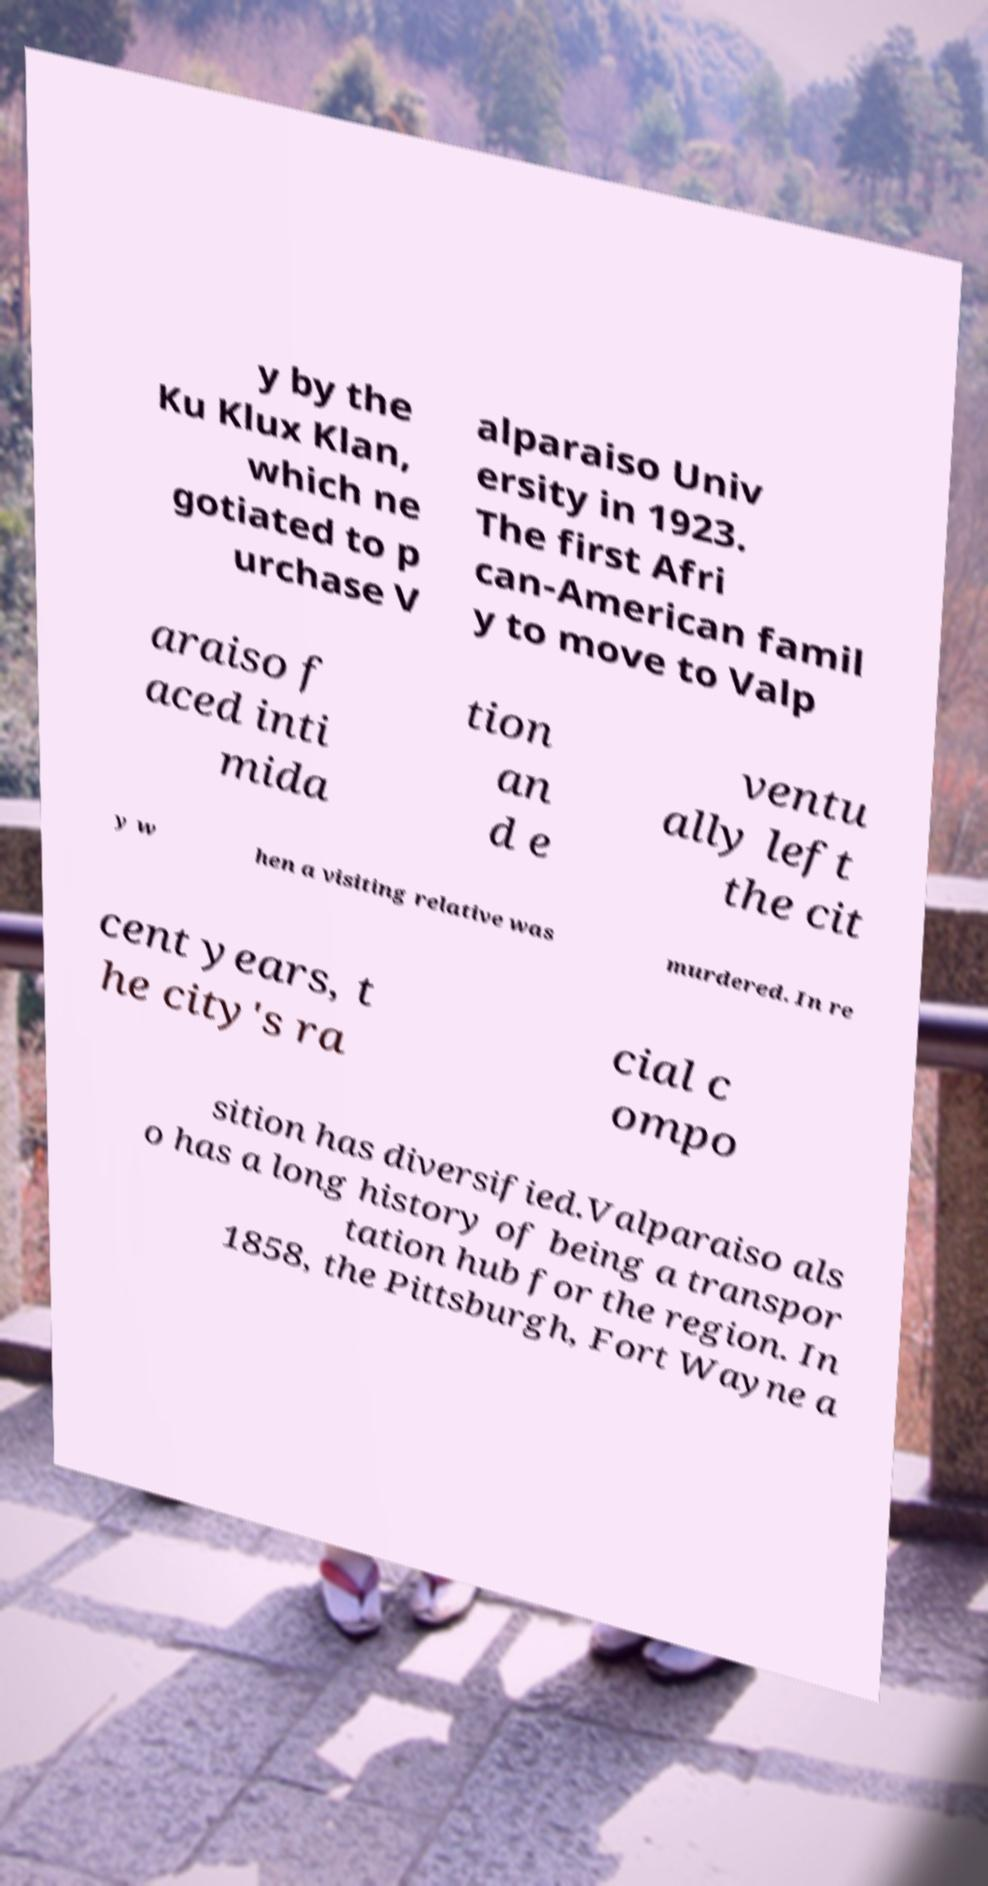For documentation purposes, I need the text within this image transcribed. Could you provide that? y by the Ku Klux Klan, which ne gotiated to p urchase V alparaiso Univ ersity in 1923. The first Afri can-American famil y to move to Valp araiso f aced inti mida tion an d e ventu ally left the cit y w hen a visiting relative was murdered. In re cent years, t he city's ra cial c ompo sition has diversified.Valparaiso als o has a long history of being a transpor tation hub for the region. In 1858, the Pittsburgh, Fort Wayne a 